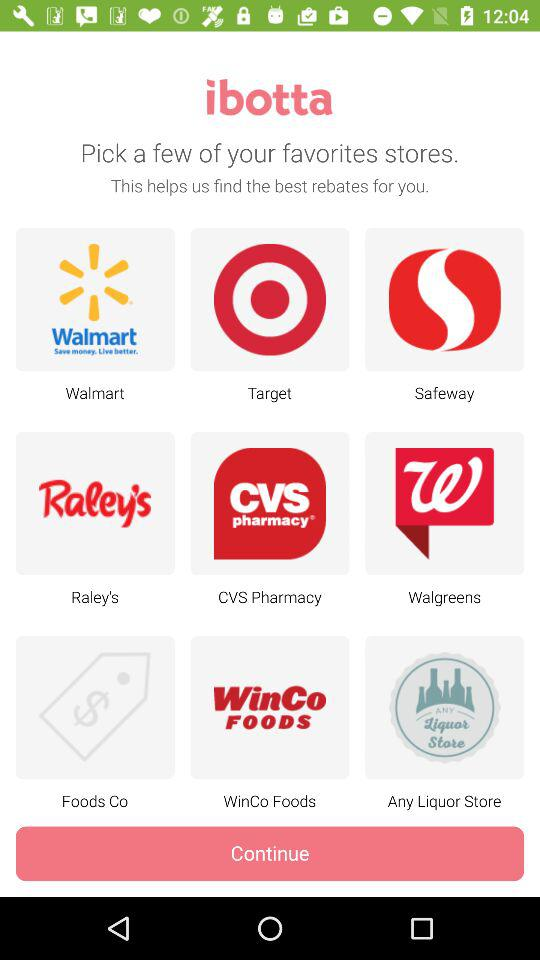What store names are available in "ibotta"? The available store names are "Walmart", "Target", "Safeway", "Raley's", "CVS Pharmacy", "Walgreens", "Foods Co", "WinCo Foods" and "Any Liquor Store". 